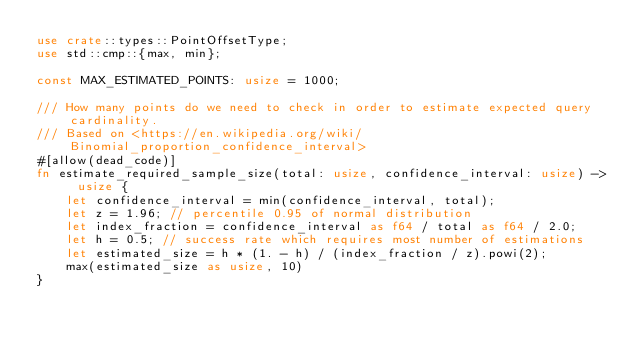Convert code to text. <code><loc_0><loc_0><loc_500><loc_500><_Rust_>use crate::types::PointOffsetType;
use std::cmp::{max, min};

const MAX_ESTIMATED_POINTS: usize = 1000;

/// How many points do we need to check in order to estimate expected query cardinality.
/// Based on <https://en.wikipedia.org/wiki/Binomial_proportion_confidence_interval>
#[allow(dead_code)]
fn estimate_required_sample_size(total: usize, confidence_interval: usize) -> usize {
    let confidence_interval = min(confidence_interval, total);
    let z = 1.96; // percentile 0.95 of normal distribution
    let index_fraction = confidence_interval as f64 / total as f64 / 2.0;
    let h = 0.5; // success rate which requires most number of estimations
    let estimated_size = h * (1. - h) / (index_fraction / z).powi(2);
    max(estimated_size as usize, 10)
}
</code> 